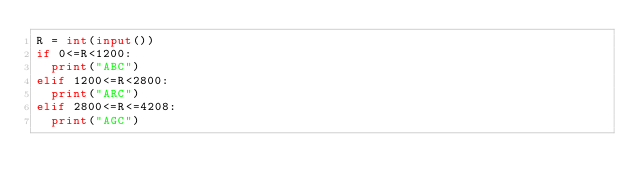Convert code to text. <code><loc_0><loc_0><loc_500><loc_500><_Python_>R = int(input())
if 0<=R<1200:
  print("ABC")
elif 1200<=R<2800:
  print("ARC")
elif 2800<=R<=4208:
  print("AGC")</code> 